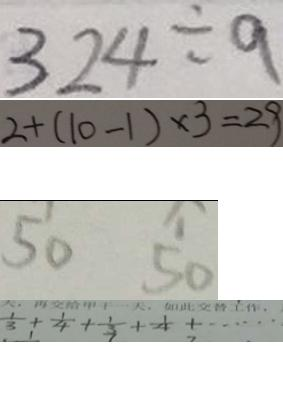Convert formula to latex. <formula><loc_0><loc_0><loc_500><loc_500>3 2 4 \div 9 
 2 + ( 1 0 - 1 ) \times 3 = 2 9 
 5 0 5 0 
 \frac { 1 } { 3 } + \frac { 1 } { 4 } + \frac { 1 } { 3 } + \frac { 1 } { 4 } + \cdots</formula> 